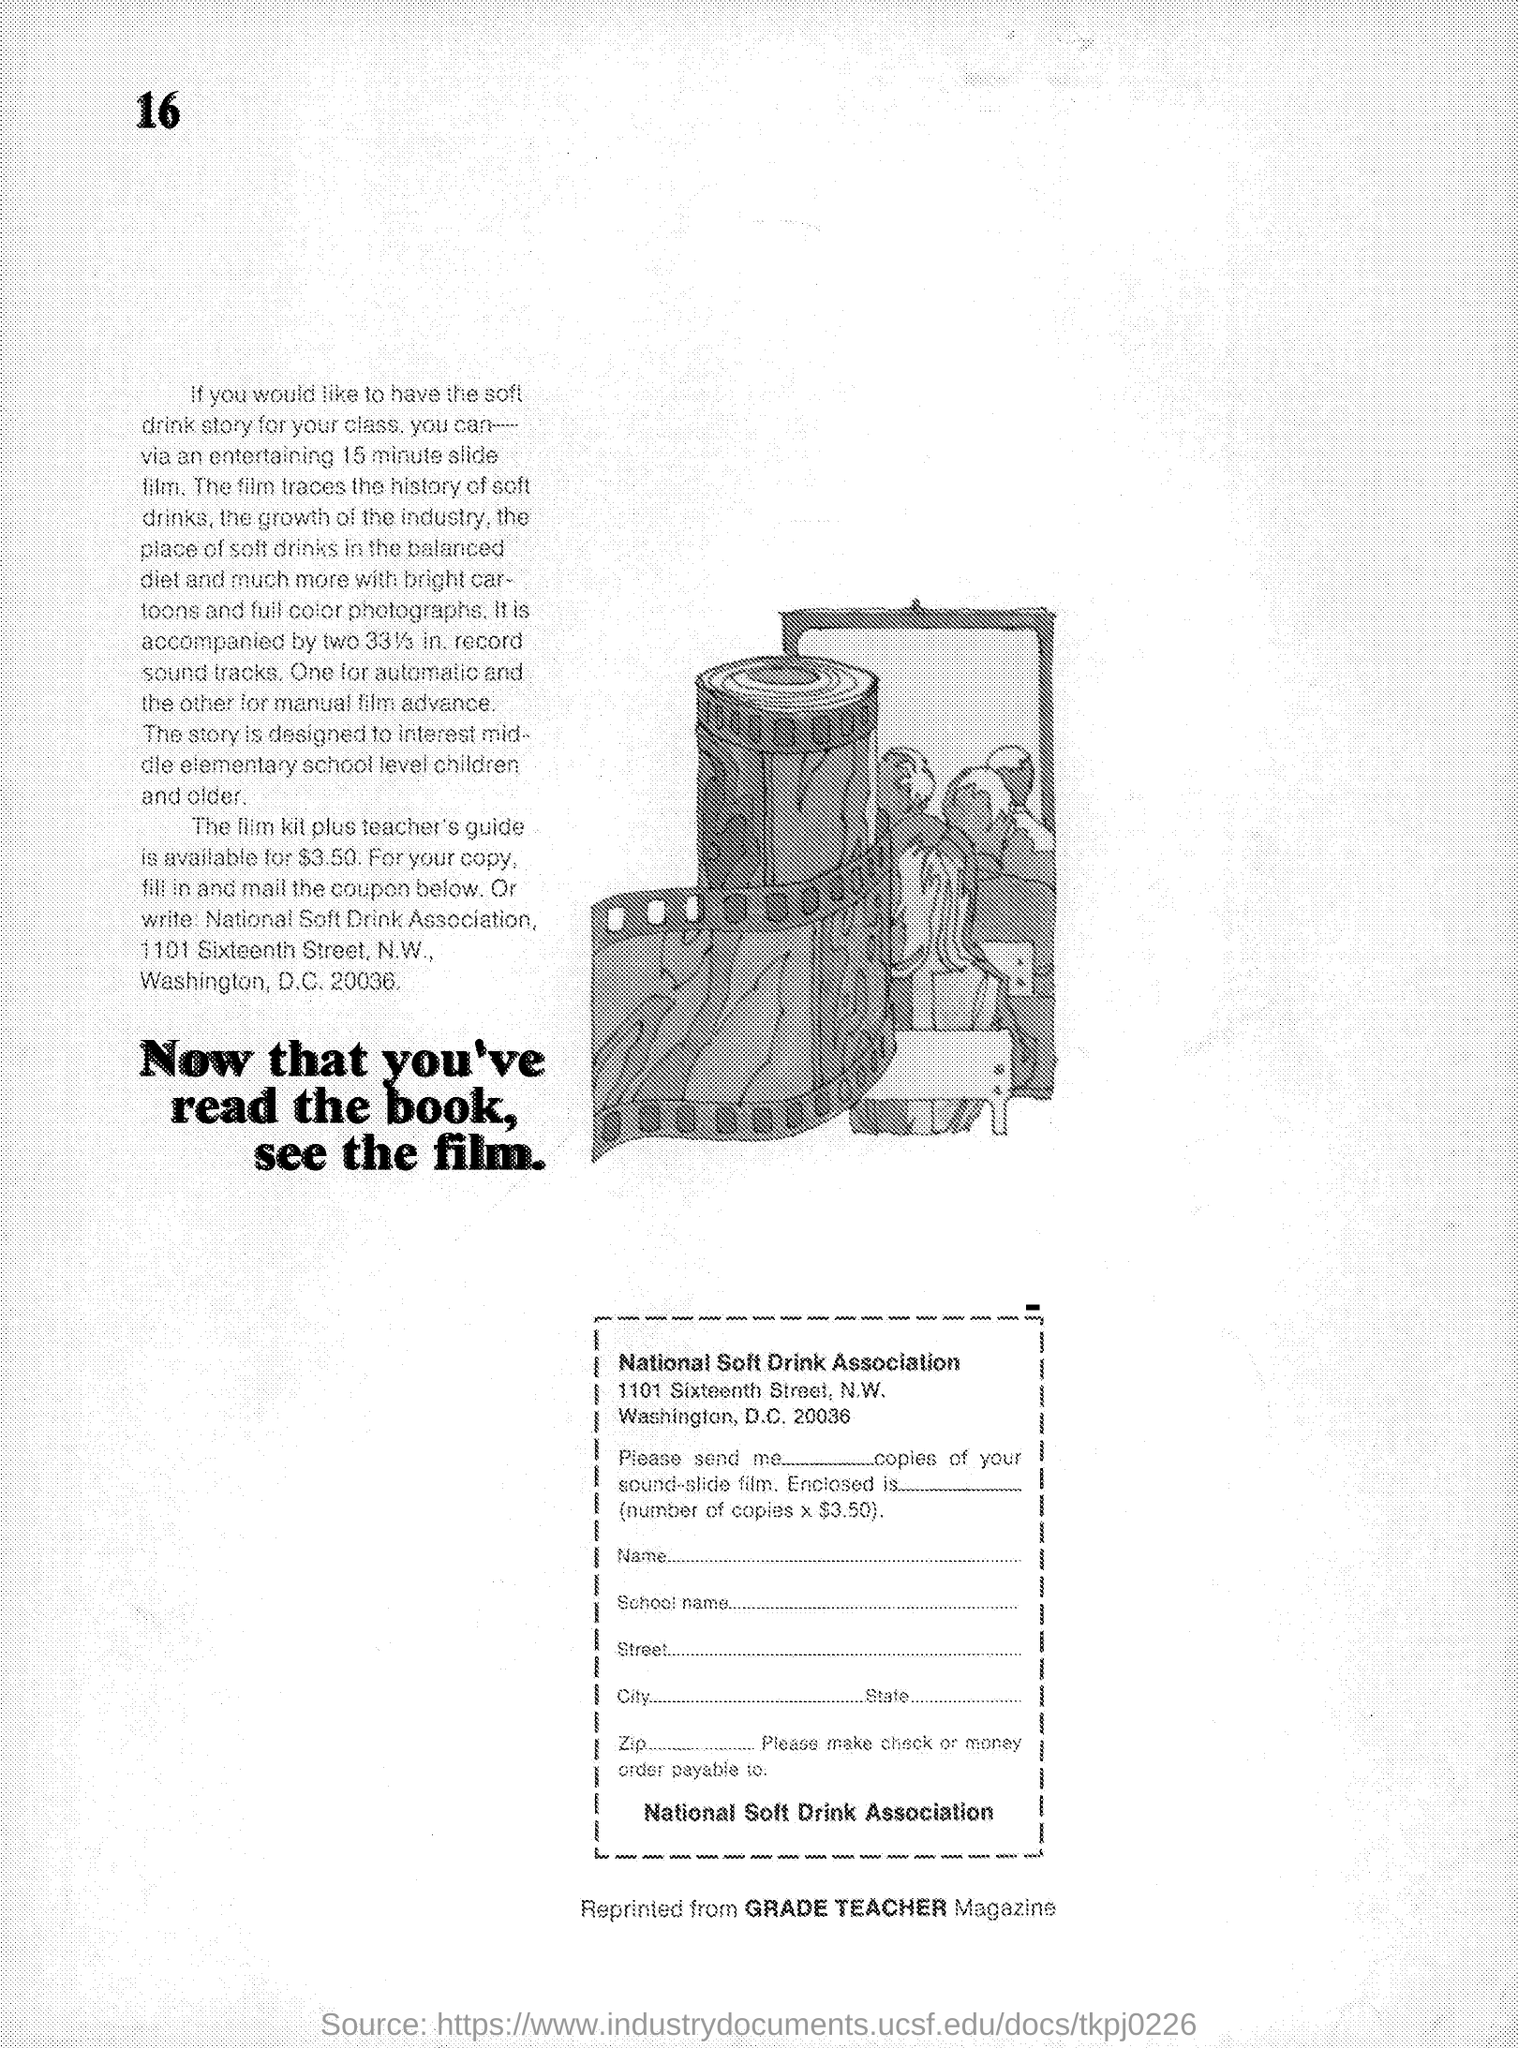For what price is the film kit plus teacher's guide available?
Your answer should be very brief. Is available for $3.50. The story is designed to interest whom?
Give a very brief answer. Middle elementary school level children and older. 